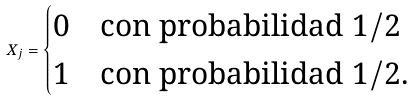Convert formula to latex. <formula><loc_0><loc_0><loc_500><loc_500>X _ { j } = \begin{cases} 0 & \text {con probabilidad $1/2$} \\ 1 & \text {con probabilidad $1/2$.} \end{cases}</formula> 